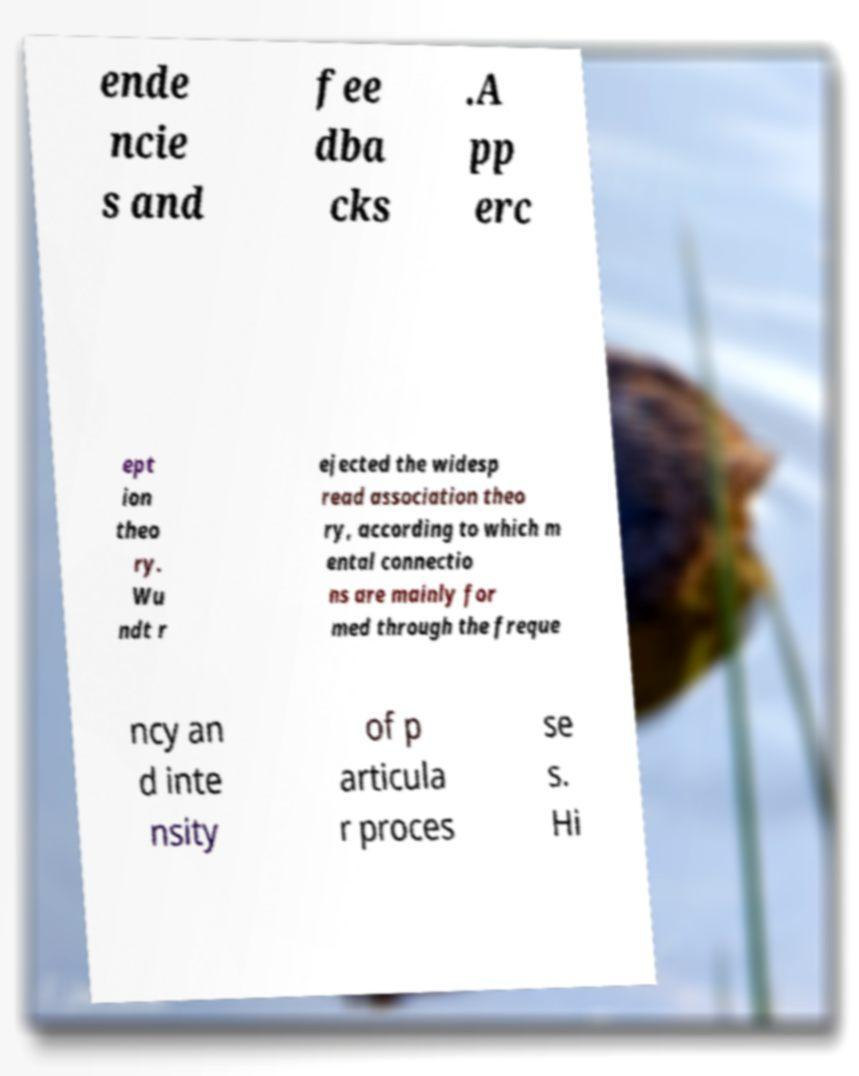Can you accurately transcribe the text from the provided image for me? ende ncie s and fee dba cks .A pp erc ept ion theo ry. Wu ndt r ejected the widesp read association theo ry, according to which m ental connectio ns are mainly for med through the freque ncy an d inte nsity of p articula r proces se s. Hi 